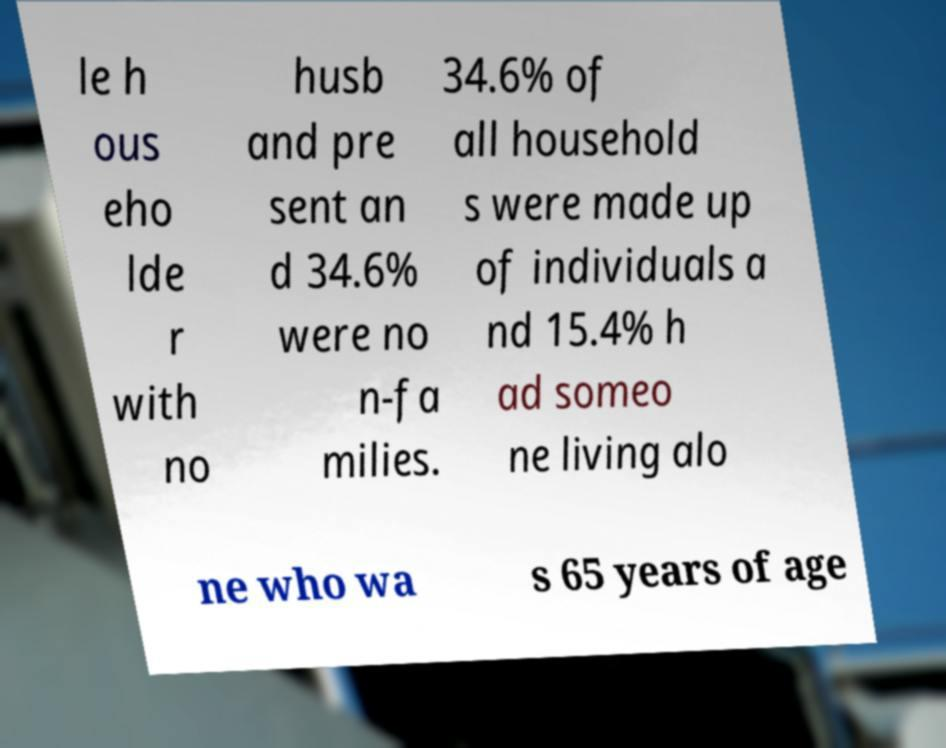I need the written content from this picture converted into text. Can you do that? le h ous eho lde r with no husb and pre sent an d 34.6% were no n-fa milies. 34.6% of all household s were made up of individuals a nd 15.4% h ad someo ne living alo ne who wa s 65 years of age 